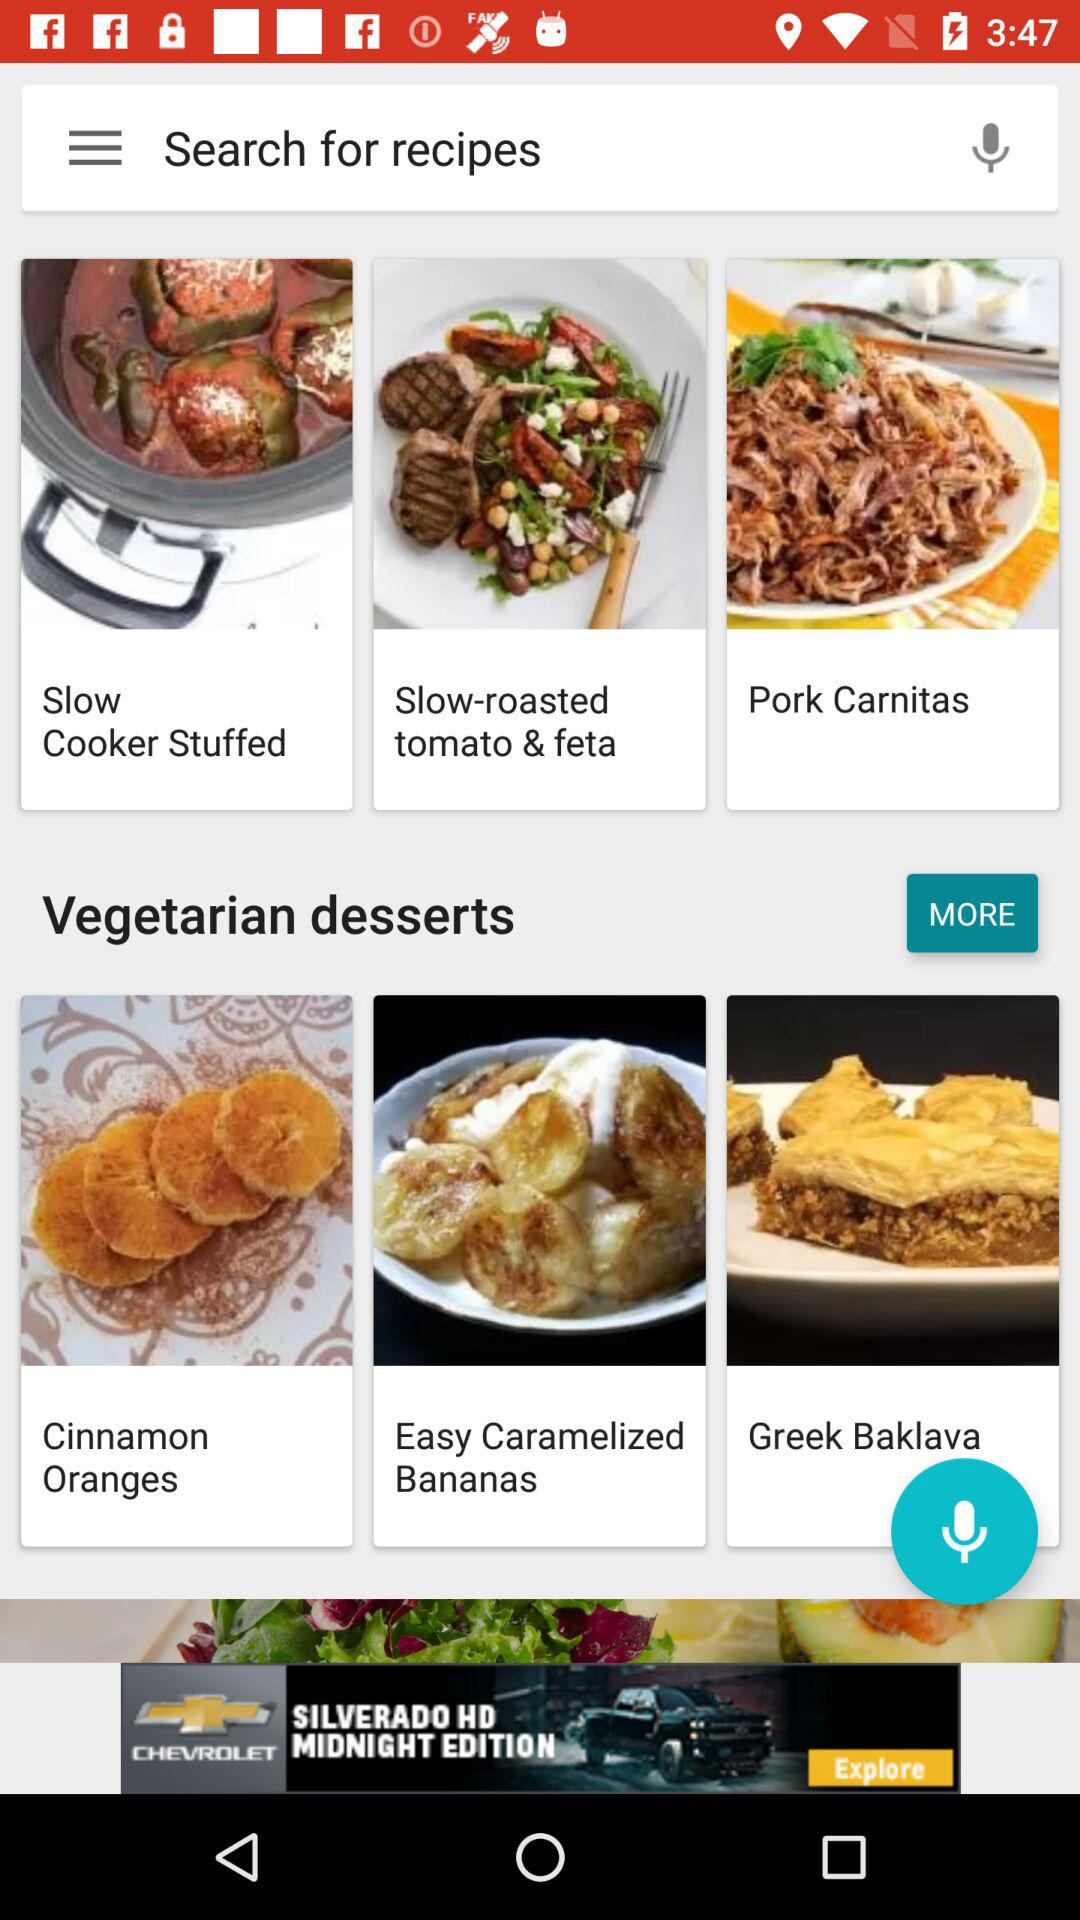Which category does "Greek Baklava" fall under? "Greek Baklava" falls under the category of vegetarian desserts. 